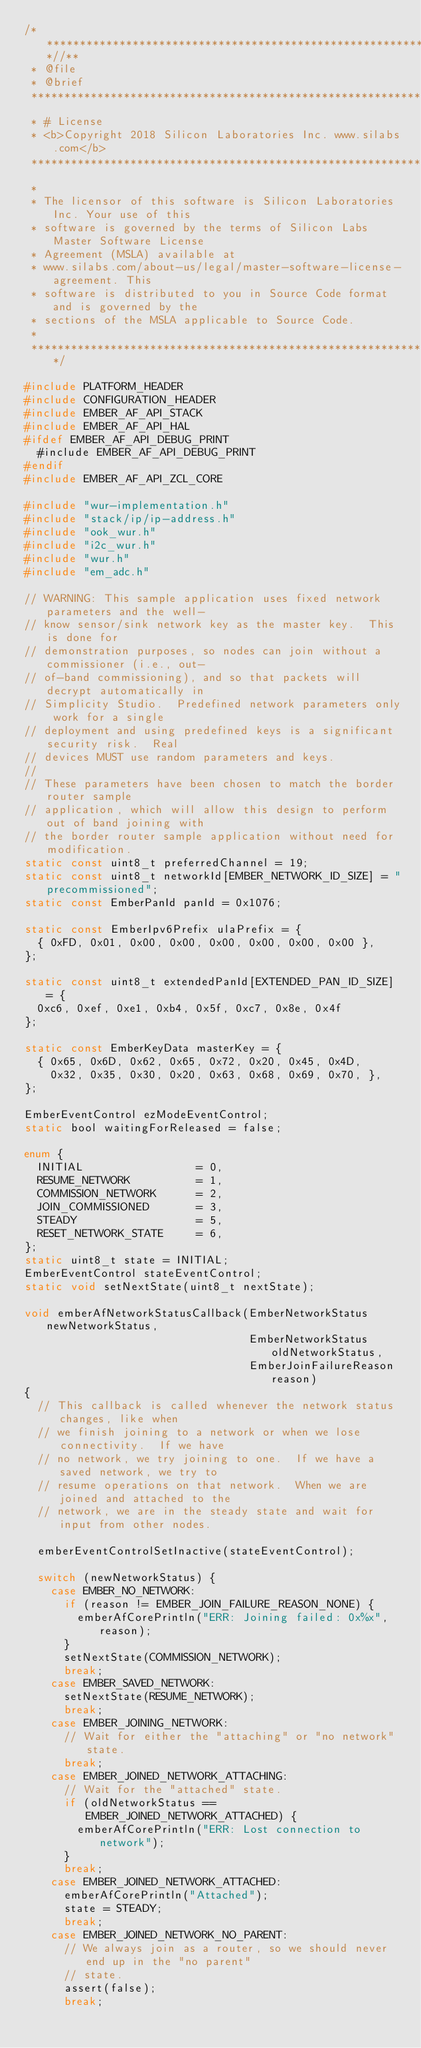Convert code to text. <code><loc_0><loc_0><loc_500><loc_500><_C_>/***************************************************************************//**
 * @file
 * @brief
 *******************************************************************************
 * # License
 * <b>Copyright 2018 Silicon Laboratories Inc. www.silabs.com</b>
 *******************************************************************************
 *
 * The licensor of this software is Silicon Laboratories Inc. Your use of this
 * software is governed by the terms of Silicon Labs Master Software License
 * Agreement (MSLA) available at
 * www.silabs.com/about-us/legal/master-software-license-agreement. This
 * software is distributed to you in Source Code format and is governed by the
 * sections of the MSLA applicable to Source Code.
 *
 ******************************************************************************/

#include PLATFORM_HEADER
#include CONFIGURATION_HEADER
#include EMBER_AF_API_STACK
#include EMBER_AF_API_HAL
#ifdef EMBER_AF_API_DEBUG_PRINT
  #include EMBER_AF_API_DEBUG_PRINT
#endif
#include EMBER_AF_API_ZCL_CORE

#include "wur-implementation.h"
#include "stack/ip/ip-address.h"
#include "ook_wur.h"
#include "i2c_wur.h"
#include "wur.h"
#include "em_adc.h"

// WARNING: This sample application uses fixed network parameters and the well-
// know sensor/sink network key as the master key.  This is done for
// demonstration purposes, so nodes can join without a commissioner (i.e., out-
// of-band commissioning), and so that packets will decrypt automatically in
// Simplicity Studio.  Predefined network parameters only work for a single
// deployment and using predefined keys is a significant security risk.  Real
// devices MUST use random parameters and keys.
//
// These parameters have been chosen to match the border router sample
// application, which will allow this design to perform out of band joining with
// the border router sample application without need for modification.
static const uint8_t preferredChannel = 19;
static const uint8_t networkId[EMBER_NETWORK_ID_SIZE] = "precommissioned";
static const EmberPanId panId = 0x1076;

static const EmberIpv6Prefix ulaPrefix = {
  { 0xFD, 0x01, 0x00, 0x00, 0x00, 0x00, 0x00, 0x00 },
};

static const uint8_t extendedPanId[EXTENDED_PAN_ID_SIZE] = {
  0xc6, 0xef, 0xe1, 0xb4, 0x5f, 0xc7, 0x8e, 0x4f
};

static const EmberKeyData masterKey = {
  { 0x65, 0x6D, 0x62, 0x65, 0x72, 0x20, 0x45, 0x4D,
    0x32, 0x35, 0x30, 0x20, 0x63, 0x68, 0x69, 0x70, },
};

EmberEventControl ezModeEventControl;
static bool waitingForReleased = false;

enum {
  INITIAL                 = 0,
  RESUME_NETWORK          = 1,
  COMMISSION_NETWORK      = 2,
  JOIN_COMMISSIONED       = 3,
  STEADY                  = 5,
  RESET_NETWORK_STATE     = 6,
};
static uint8_t state = INITIAL;
EmberEventControl stateEventControl;
static void setNextState(uint8_t nextState);

void emberAfNetworkStatusCallback(EmberNetworkStatus newNetworkStatus,
                                  EmberNetworkStatus oldNetworkStatus,
                                  EmberJoinFailureReason reason)
{
  // This callback is called whenever the network status changes, like when
  // we finish joining to a network or when we lose connectivity.  If we have
  // no network, we try joining to one.  If we have a saved network, we try to
  // resume operations on that network.  When we are joined and attached to the
  // network, we are in the steady state and wait for input from other nodes.

  emberEventControlSetInactive(stateEventControl);

  switch (newNetworkStatus) {
    case EMBER_NO_NETWORK:
      if (reason != EMBER_JOIN_FAILURE_REASON_NONE) {
        emberAfCorePrintln("ERR: Joining failed: 0x%x", reason);
      }
      setNextState(COMMISSION_NETWORK);
      break;
    case EMBER_SAVED_NETWORK:
      setNextState(RESUME_NETWORK);
      break;
    case EMBER_JOINING_NETWORK:
      // Wait for either the "attaching" or "no network" state.
      break;
    case EMBER_JOINED_NETWORK_ATTACHING:
      // Wait for the "attached" state.
      if (oldNetworkStatus == EMBER_JOINED_NETWORK_ATTACHED) {
        emberAfCorePrintln("ERR: Lost connection to network");
      }
      break;
    case EMBER_JOINED_NETWORK_ATTACHED:
      emberAfCorePrintln("Attached");
      state = STEADY;
      break;
    case EMBER_JOINED_NETWORK_NO_PARENT:
      // We always join as a router, so we should never end up in the "no parent"
      // state.
      assert(false);
      break;</code> 